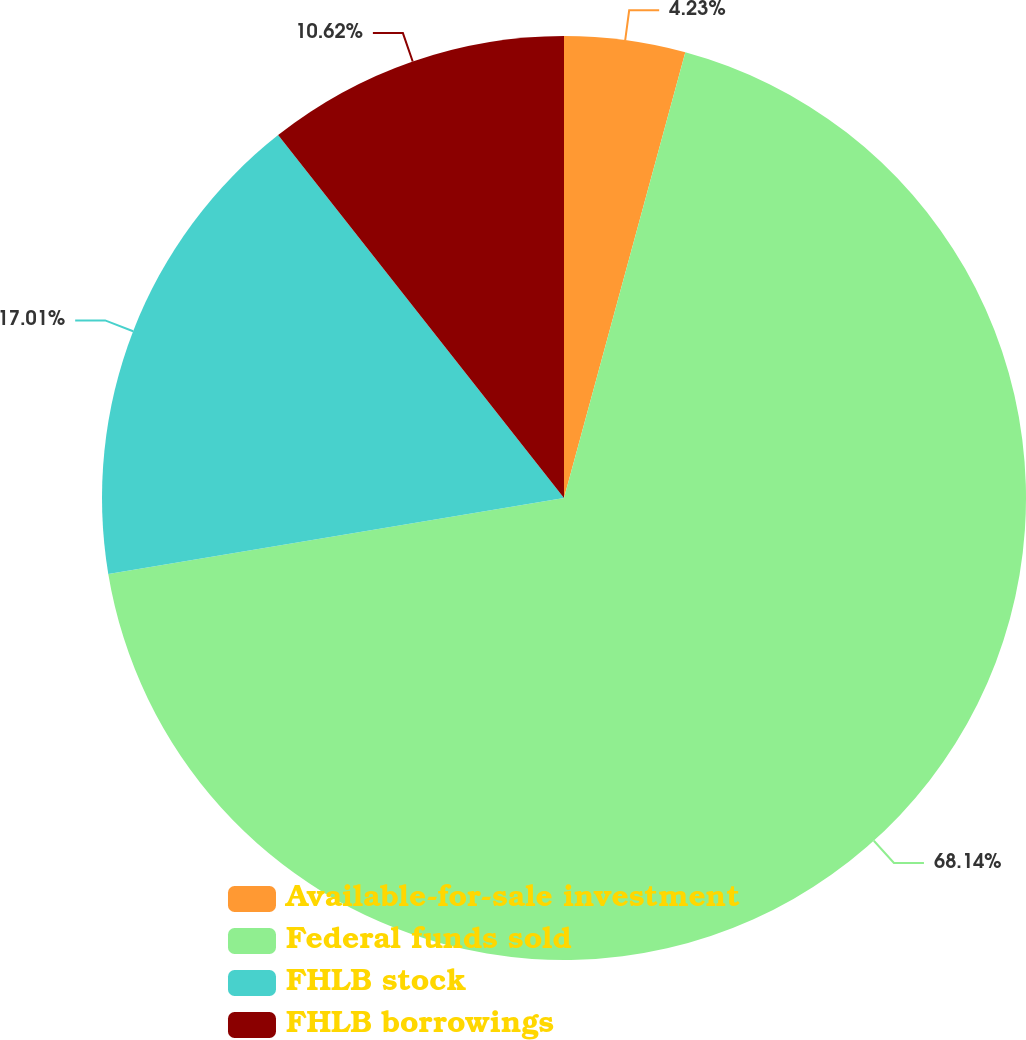Convert chart to OTSL. <chart><loc_0><loc_0><loc_500><loc_500><pie_chart><fcel>Available-for-sale investment<fcel>Federal funds sold<fcel>FHLB stock<fcel>FHLB borrowings<nl><fcel>4.23%<fcel>68.15%<fcel>17.01%<fcel>10.62%<nl></chart> 